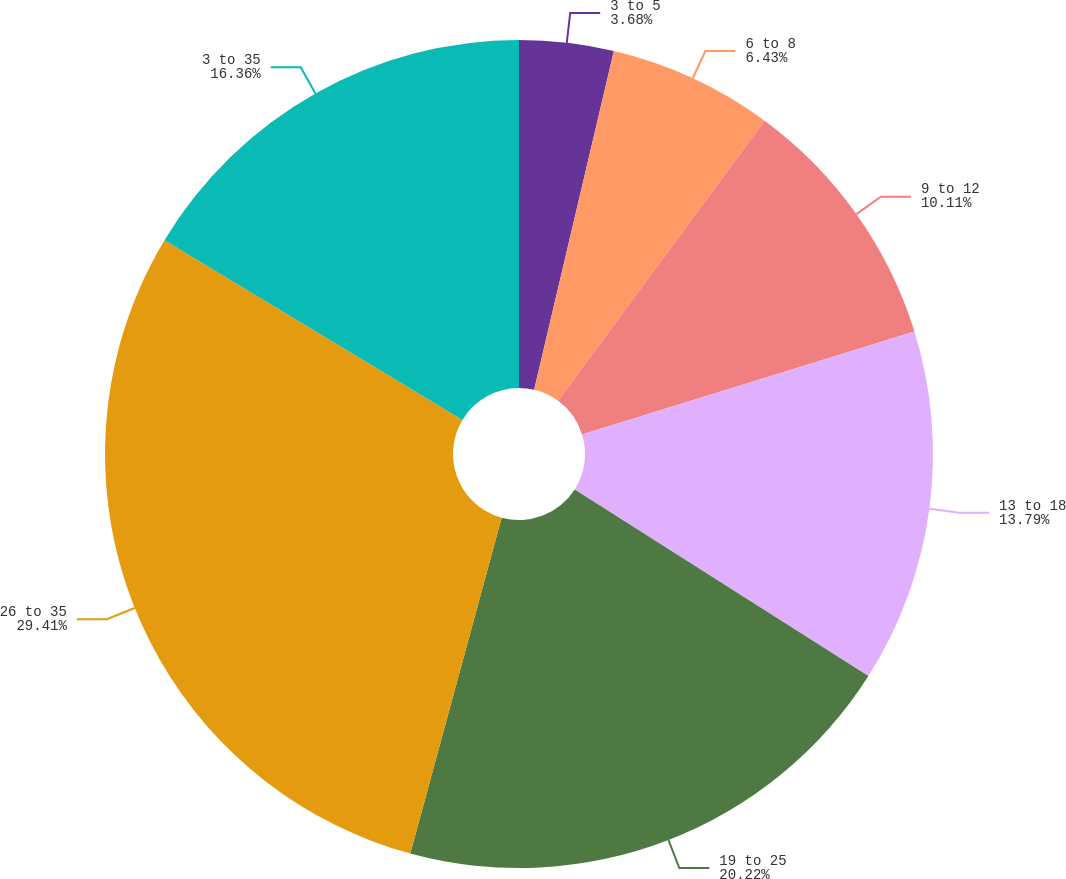<chart> <loc_0><loc_0><loc_500><loc_500><pie_chart><fcel>3 to 5<fcel>6 to 8<fcel>9 to 12<fcel>13 to 18<fcel>19 to 25<fcel>26 to 35<fcel>3 to 35<nl><fcel>3.68%<fcel>6.43%<fcel>10.11%<fcel>13.79%<fcel>20.22%<fcel>29.41%<fcel>16.36%<nl></chart> 